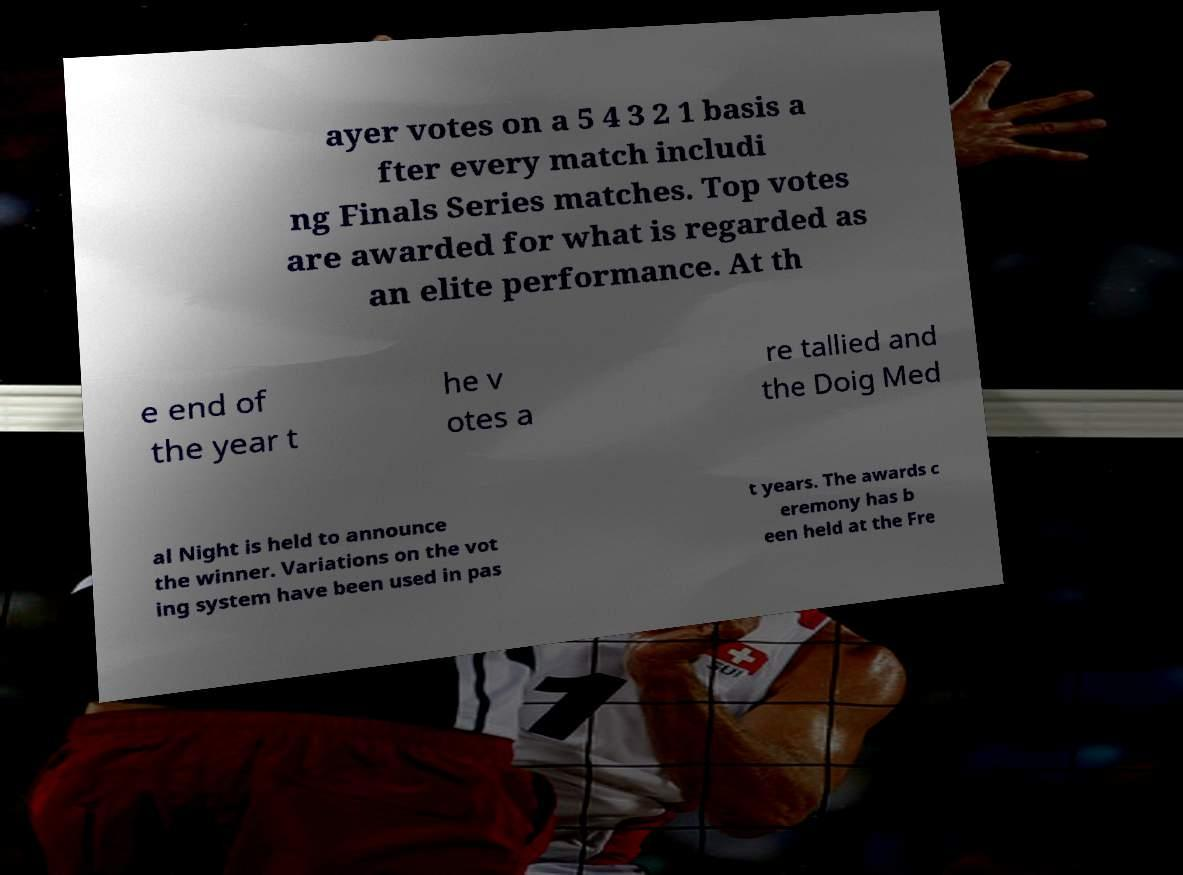What messages or text are displayed in this image? I need them in a readable, typed format. ayer votes on a 5 4 3 2 1 basis a fter every match includi ng Finals Series matches. Top votes are awarded for what is regarded as an elite performance. At th e end of the year t he v otes a re tallied and the Doig Med al Night is held to announce the winner. Variations on the vot ing system have been used in pas t years. The awards c eremony has b een held at the Fre 